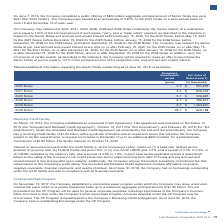According to Lam Research Corporation's financial document, What is the annual interest rate the Company will pay on the 2026 Notes? Based on the financial document, the answer is 3.75%. Also, What is the aggregate principal amount of Senior Notes due June 2021? According to the financial document, $800 million. The relevant text states: ", 2016, the Company completed a public offering of $800 million aggregate principal amount of Senior Notes due June 2021 (the “2021 Notes”). The Company pays intere..." Also, What is the interest at annual rate that the Company will pay on the 2021 Notes? According to the financial document, 2.80%. The relevant text states: "”). The Company pays interest at an annual rate of 2.80% on the 2021 Notes on a semi-annual basis on June 15 and December 15 of each year...." Additionally, Which notes has the highest fair value? According to the financial document, 2029. The relevant text states: "he Company may redeem the 2020, 2021, 2025, 2026, 2029 and 2049 Notes (collectively the “Senior Notes”) at a redemption price equal to 100% of the princip..." Additionally, Which notes has the highest remaining amortization period? According to the financial document, 2049. The relevant text states: "y may redeem the 2020, 2021, 2025, 2026, 2029 and 2049 Notes (collectively the “Senior Notes”) at a redemption price equal to 100% of the principal amount..." Also, can you calculate: What is the annual interest expense on the 2021 Notes? Based on the calculation: 800*2.80%, the result is 22.4 (in millions). This is based on the information: "). The Company pays interest at an annual rate of 2.80% on the 2021 Notes on a semi-annual basis on June 15 and December 15 of each year. 2016, the Company completed a public offering of $800 million ..." The key data points involved are: 2.80, 800. 